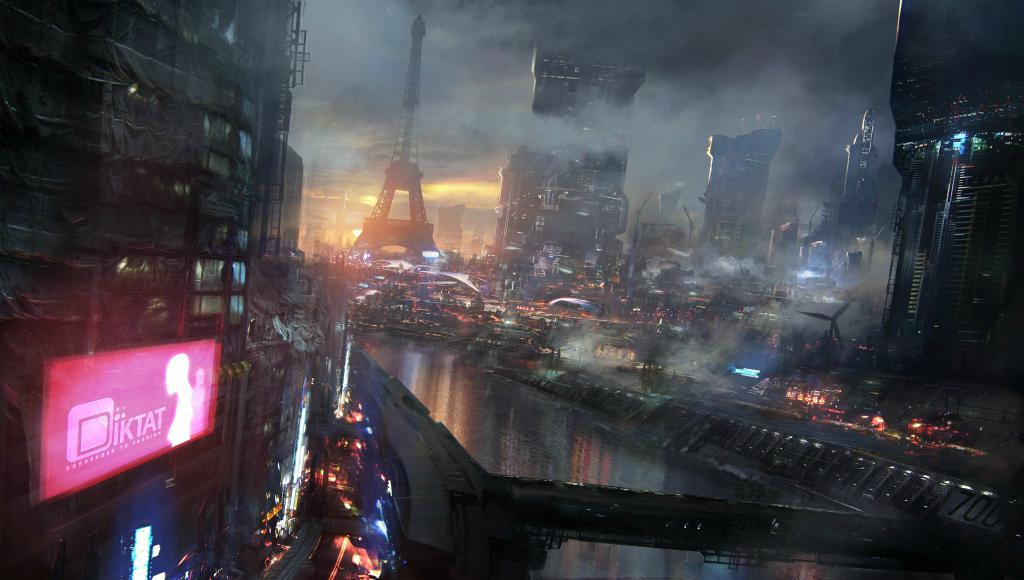What type of buildings can be seen in the image? There are skyscrapers in the image. Are there any sources of light visible in the image? Yes, there are lights in the image. What can be found on the left side of the image? There is a poster on the left side of the image. What is located at the top side of the image? There is a tower at the top side of the image. What type of card is being used to fan the heat in the image? There is no card or heat present in the image; it features skyscrapers, lights, a poster, and a tower. 